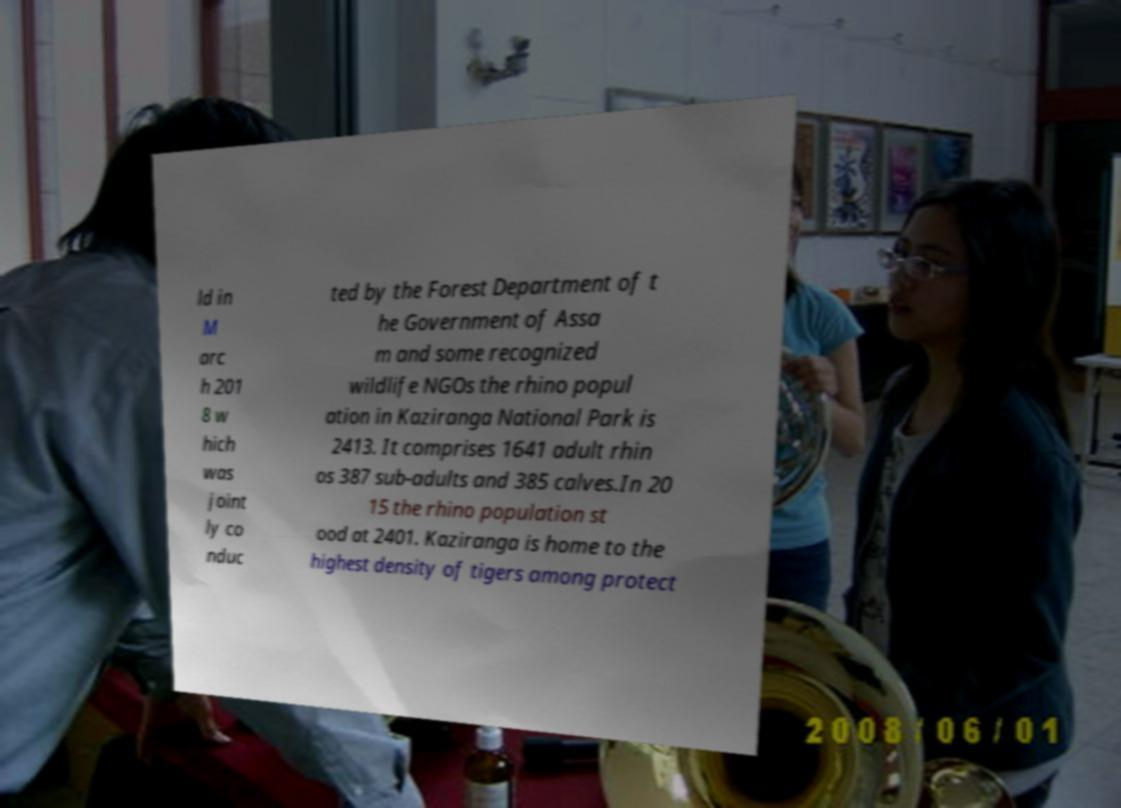For documentation purposes, I need the text within this image transcribed. Could you provide that? ld in M arc h 201 8 w hich was joint ly co nduc ted by the Forest Department of t he Government of Assa m and some recognized wildlife NGOs the rhino popul ation in Kaziranga National Park is 2413. It comprises 1641 adult rhin os 387 sub-adults and 385 calves.In 20 15 the rhino population st ood at 2401. Kaziranga is home to the highest density of tigers among protect 